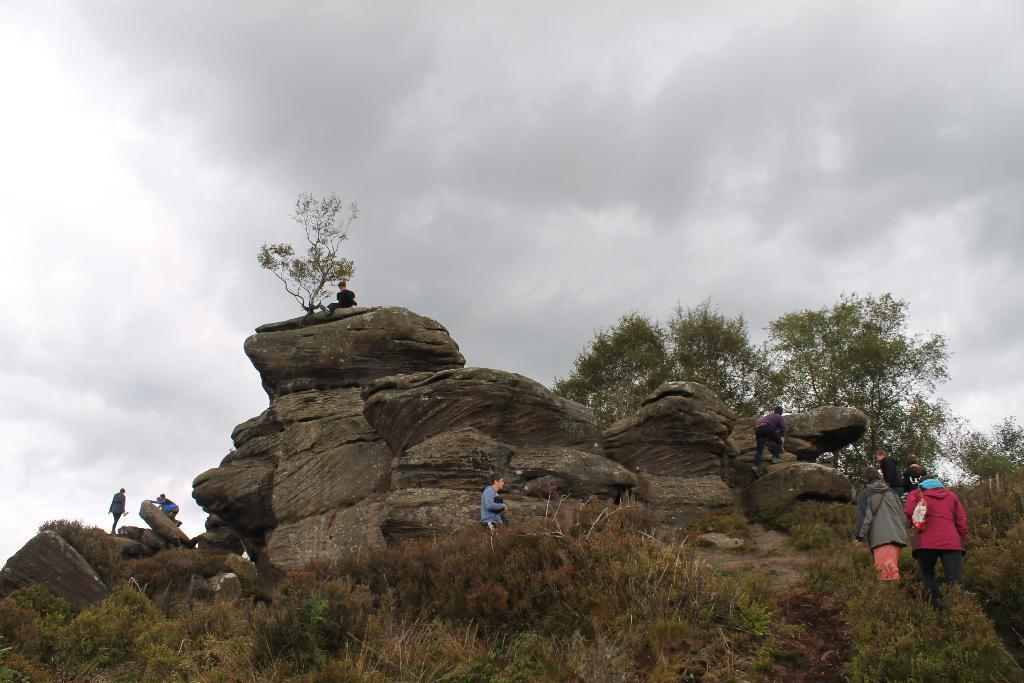Who or what can be seen in the image? There are people in the image. What type of natural features are present in the image? There are rock hills, trees, plants, and grass visible in the image. What is visible in the sky in the image? The sky is visible in the image, and clouds are present. Where is the table located in the image? There is no table present in the image. Can you describe how the people are stretching in the image? There is no indication in the image that the people are stretching; they are simply visible. 